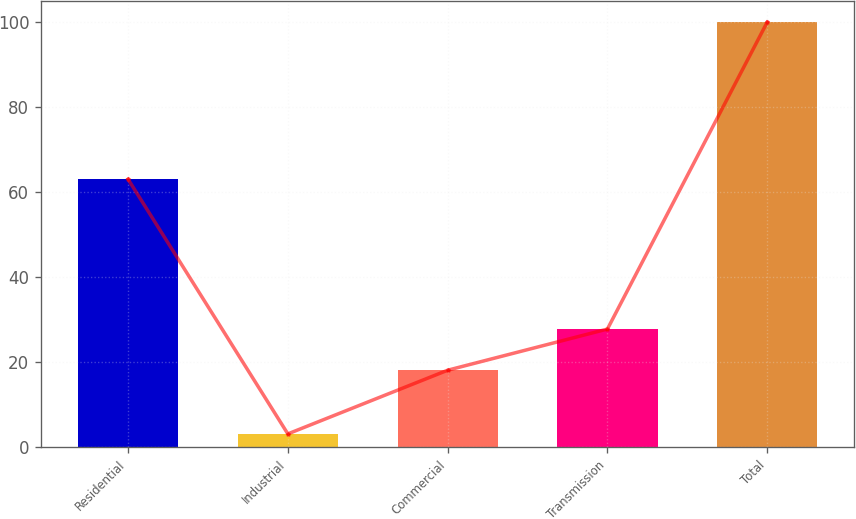Convert chart to OTSL. <chart><loc_0><loc_0><loc_500><loc_500><bar_chart><fcel>Residential<fcel>Industrial<fcel>Commercial<fcel>Transmission<fcel>Total<nl><fcel>63<fcel>3<fcel>18<fcel>27.7<fcel>100<nl></chart> 